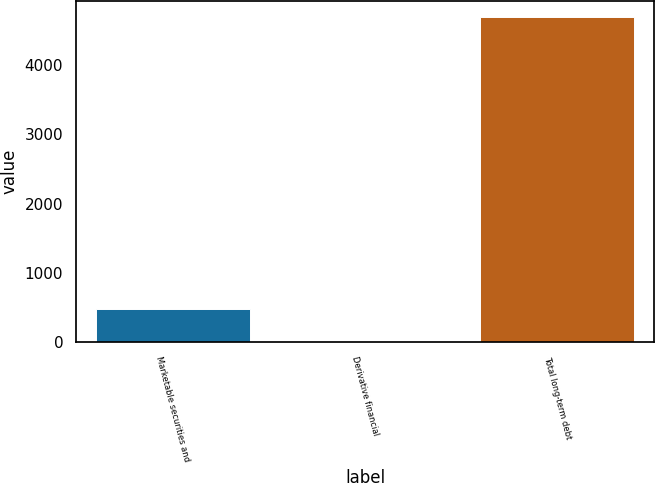<chart> <loc_0><loc_0><loc_500><loc_500><bar_chart><fcel>Marketable securities and<fcel>Derivative financial<fcel>Total long-term debt<nl><fcel>477.53<fcel>9.7<fcel>4688<nl></chart> 